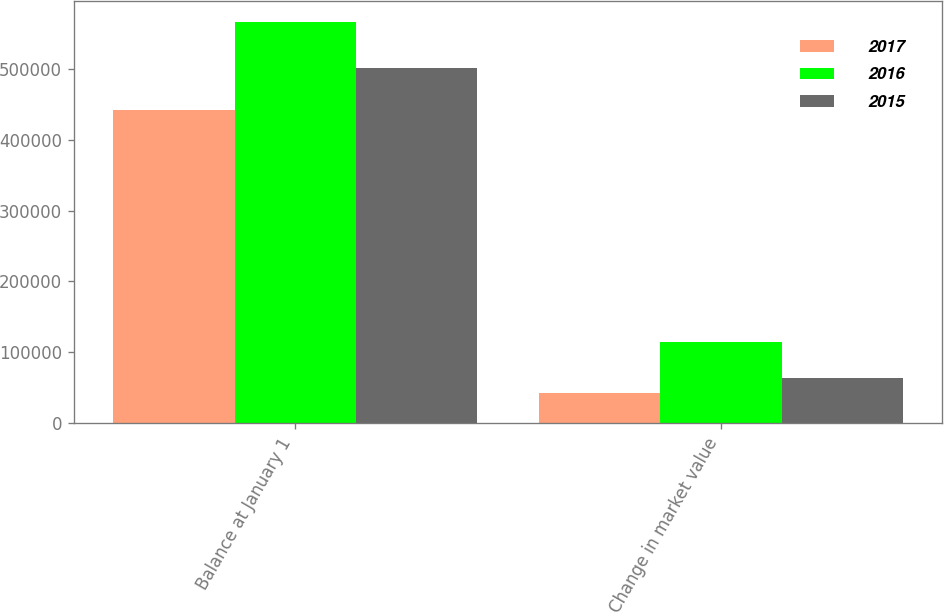<chart> <loc_0><loc_0><loc_500><loc_500><stacked_bar_chart><ecel><fcel>Balance at January 1<fcel>Change in market value<nl><fcel>2017<fcel>442092<fcel>41916<nl><fcel>2016<fcel>566783<fcel>115093<nl><fcel>2015<fcel>500733<fcel>64378<nl></chart> 